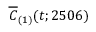<formula> <loc_0><loc_0><loc_500><loc_500>\overline { C } _ { ( 1 ) } ( t ; 2 5 0 6 )</formula> 